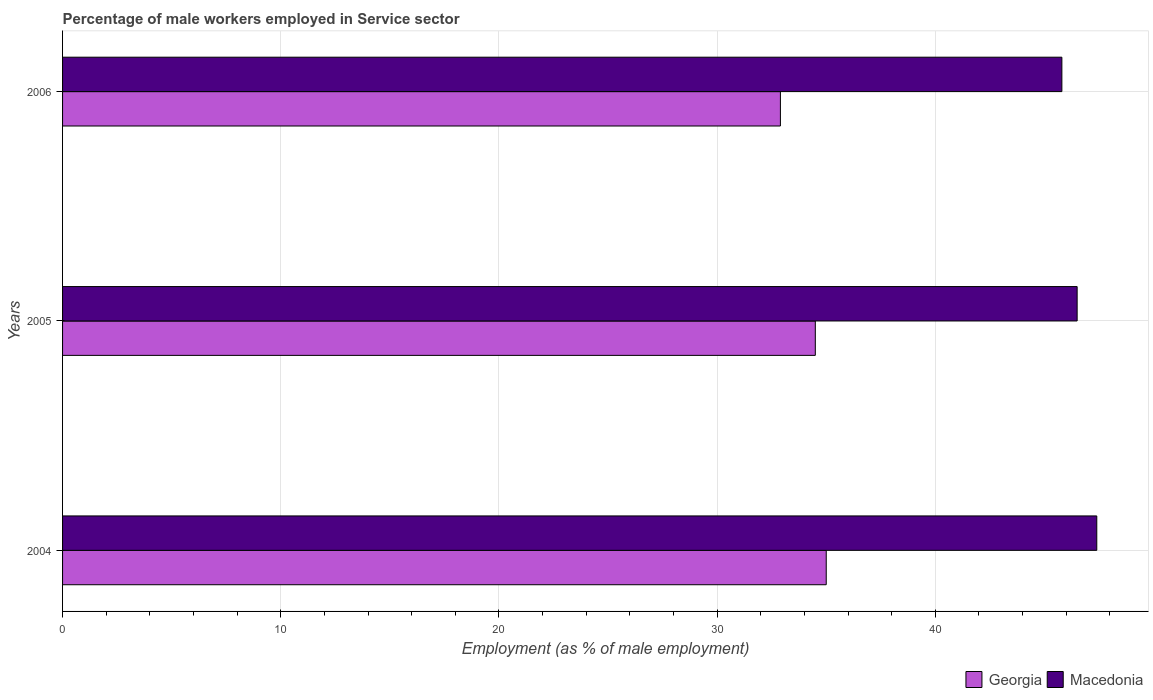How many groups of bars are there?
Give a very brief answer. 3. Are the number of bars per tick equal to the number of legend labels?
Your answer should be very brief. Yes. Are the number of bars on each tick of the Y-axis equal?
Keep it short and to the point. Yes. What is the label of the 1st group of bars from the top?
Your answer should be compact. 2006. What is the percentage of male workers employed in Service sector in Georgia in 2005?
Make the answer very short. 34.5. Across all years, what is the maximum percentage of male workers employed in Service sector in Macedonia?
Make the answer very short. 47.4. Across all years, what is the minimum percentage of male workers employed in Service sector in Georgia?
Keep it short and to the point. 32.9. In which year was the percentage of male workers employed in Service sector in Macedonia maximum?
Ensure brevity in your answer.  2004. In which year was the percentage of male workers employed in Service sector in Georgia minimum?
Your answer should be very brief. 2006. What is the total percentage of male workers employed in Service sector in Macedonia in the graph?
Give a very brief answer. 139.7. What is the difference between the percentage of male workers employed in Service sector in Macedonia in 2004 and that in 2005?
Offer a very short reply. 0.9. What is the difference between the percentage of male workers employed in Service sector in Macedonia in 2006 and the percentage of male workers employed in Service sector in Georgia in 2005?
Your answer should be compact. 11.3. What is the average percentage of male workers employed in Service sector in Macedonia per year?
Give a very brief answer. 46.57. In the year 2004, what is the difference between the percentage of male workers employed in Service sector in Macedonia and percentage of male workers employed in Service sector in Georgia?
Offer a very short reply. 12.4. In how many years, is the percentage of male workers employed in Service sector in Macedonia greater than 12 %?
Your answer should be compact. 3. What is the ratio of the percentage of male workers employed in Service sector in Georgia in 2004 to that in 2005?
Your answer should be very brief. 1.01. Is the percentage of male workers employed in Service sector in Georgia in 2004 less than that in 2006?
Your response must be concise. No. What is the difference between the highest and the second highest percentage of male workers employed in Service sector in Georgia?
Your response must be concise. 0.5. What is the difference between the highest and the lowest percentage of male workers employed in Service sector in Macedonia?
Your answer should be very brief. 1.6. What does the 1st bar from the top in 2005 represents?
Offer a terse response. Macedonia. What does the 2nd bar from the bottom in 2005 represents?
Offer a terse response. Macedonia. How many years are there in the graph?
Keep it short and to the point. 3. Does the graph contain any zero values?
Your answer should be compact. No. Does the graph contain grids?
Your answer should be very brief. Yes. Where does the legend appear in the graph?
Keep it short and to the point. Bottom right. What is the title of the graph?
Offer a terse response. Percentage of male workers employed in Service sector. Does "Honduras" appear as one of the legend labels in the graph?
Offer a very short reply. No. What is the label or title of the X-axis?
Provide a short and direct response. Employment (as % of male employment). What is the Employment (as % of male employment) in Georgia in 2004?
Your response must be concise. 35. What is the Employment (as % of male employment) of Macedonia in 2004?
Your answer should be very brief. 47.4. What is the Employment (as % of male employment) in Georgia in 2005?
Keep it short and to the point. 34.5. What is the Employment (as % of male employment) of Macedonia in 2005?
Keep it short and to the point. 46.5. What is the Employment (as % of male employment) in Georgia in 2006?
Your answer should be compact. 32.9. What is the Employment (as % of male employment) of Macedonia in 2006?
Make the answer very short. 45.8. Across all years, what is the maximum Employment (as % of male employment) of Georgia?
Offer a very short reply. 35. Across all years, what is the maximum Employment (as % of male employment) in Macedonia?
Provide a succinct answer. 47.4. Across all years, what is the minimum Employment (as % of male employment) in Georgia?
Provide a succinct answer. 32.9. Across all years, what is the minimum Employment (as % of male employment) in Macedonia?
Ensure brevity in your answer.  45.8. What is the total Employment (as % of male employment) in Georgia in the graph?
Ensure brevity in your answer.  102.4. What is the total Employment (as % of male employment) of Macedonia in the graph?
Offer a terse response. 139.7. What is the difference between the Employment (as % of male employment) of Georgia in 2004 and the Employment (as % of male employment) of Macedonia in 2005?
Your answer should be very brief. -11.5. What is the difference between the Employment (as % of male employment) in Georgia in 2005 and the Employment (as % of male employment) in Macedonia in 2006?
Your response must be concise. -11.3. What is the average Employment (as % of male employment) in Georgia per year?
Offer a terse response. 34.13. What is the average Employment (as % of male employment) in Macedonia per year?
Provide a succinct answer. 46.57. In the year 2005, what is the difference between the Employment (as % of male employment) of Georgia and Employment (as % of male employment) of Macedonia?
Provide a short and direct response. -12. What is the ratio of the Employment (as % of male employment) in Georgia in 2004 to that in 2005?
Offer a very short reply. 1.01. What is the ratio of the Employment (as % of male employment) of Macedonia in 2004 to that in 2005?
Keep it short and to the point. 1.02. What is the ratio of the Employment (as % of male employment) in Georgia in 2004 to that in 2006?
Your answer should be compact. 1.06. What is the ratio of the Employment (as % of male employment) in Macedonia in 2004 to that in 2006?
Provide a short and direct response. 1.03. What is the ratio of the Employment (as % of male employment) of Georgia in 2005 to that in 2006?
Offer a terse response. 1.05. What is the ratio of the Employment (as % of male employment) in Macedonia in 2005 to that in 2006?
Make the answer very short. 1.02. What is the difference between the highest and the lowest Employment (as % of male employment) of Georgia?
Keep it short and to the point. 2.1. 